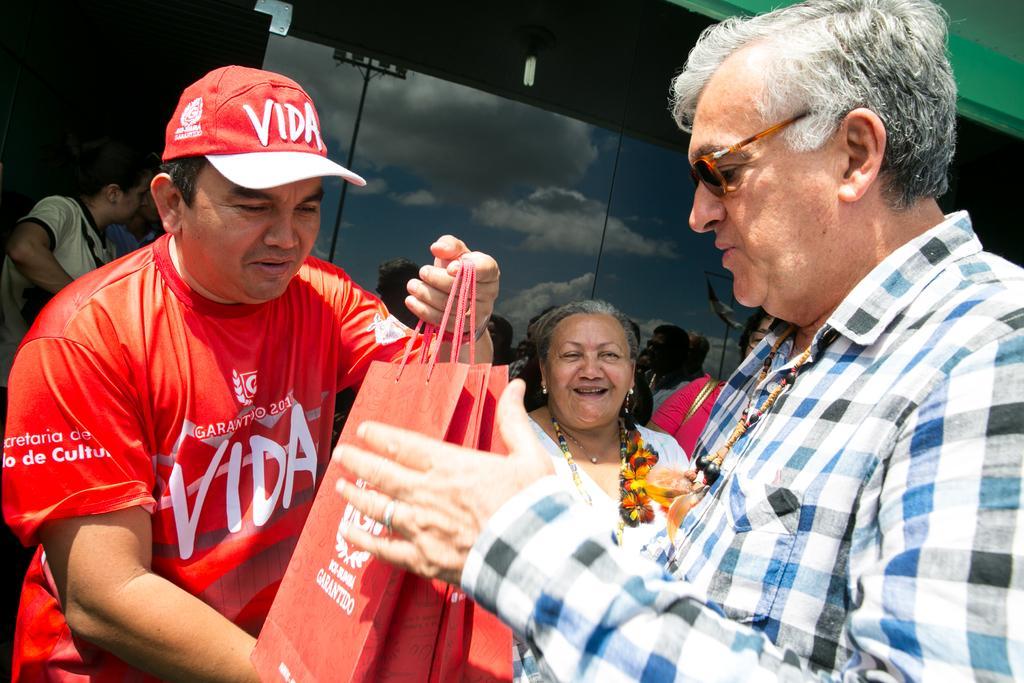Could you give a brief overview of what you see in this image? This man is holding bags. Here we can see people. On this glass there is a reflection of sky and clouds. 